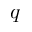Convert formula to latex. <formula><loc_0><loc_0><loc_500><loc_500>q</formula> 